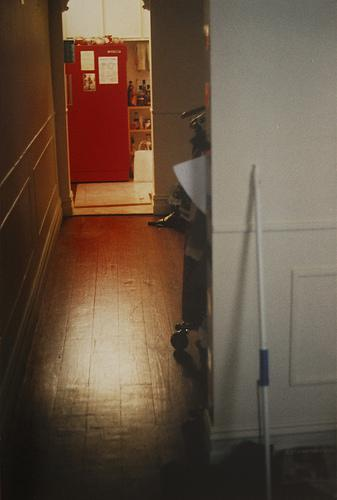Question: where was the photo taken?
Choices:
A. In a house.
B. In a barn.
C. In a closet.
D. At a park.
Answer with the letter. Answer: A Question: how many fridges are in the picture?
Choices:
A. One.
B. Two.
C. Three.
D. Four.
Answer with the letter. Answer: A Question: what is red?
Choices:
A. The apple.
B. The fridge.
C. The car.
D. The table.
Answer with the letter. Answer: B Question: what is wooden?
Choices:
A. The table.
B. The chair.
C. The house.
D. The floor.
Answer with the letter. Answer: D Question: what is white?
Choices:
A. A mop handle.
B. The fence.
C. The snow.
D. The clouds.
Answer with the letter. Answer: A Question: where is a light reflection?
Choices:
A. On the lake.
B. The refrigerator.
C. The mirror.
D. On the floor.
Answer with the letter. Answer: D Question: where are papers posted?
Choices:
A. On the cork board.
B. The desk.
C. On the wall.
D. On the fridge.
Answer with the letter. Answer: D 